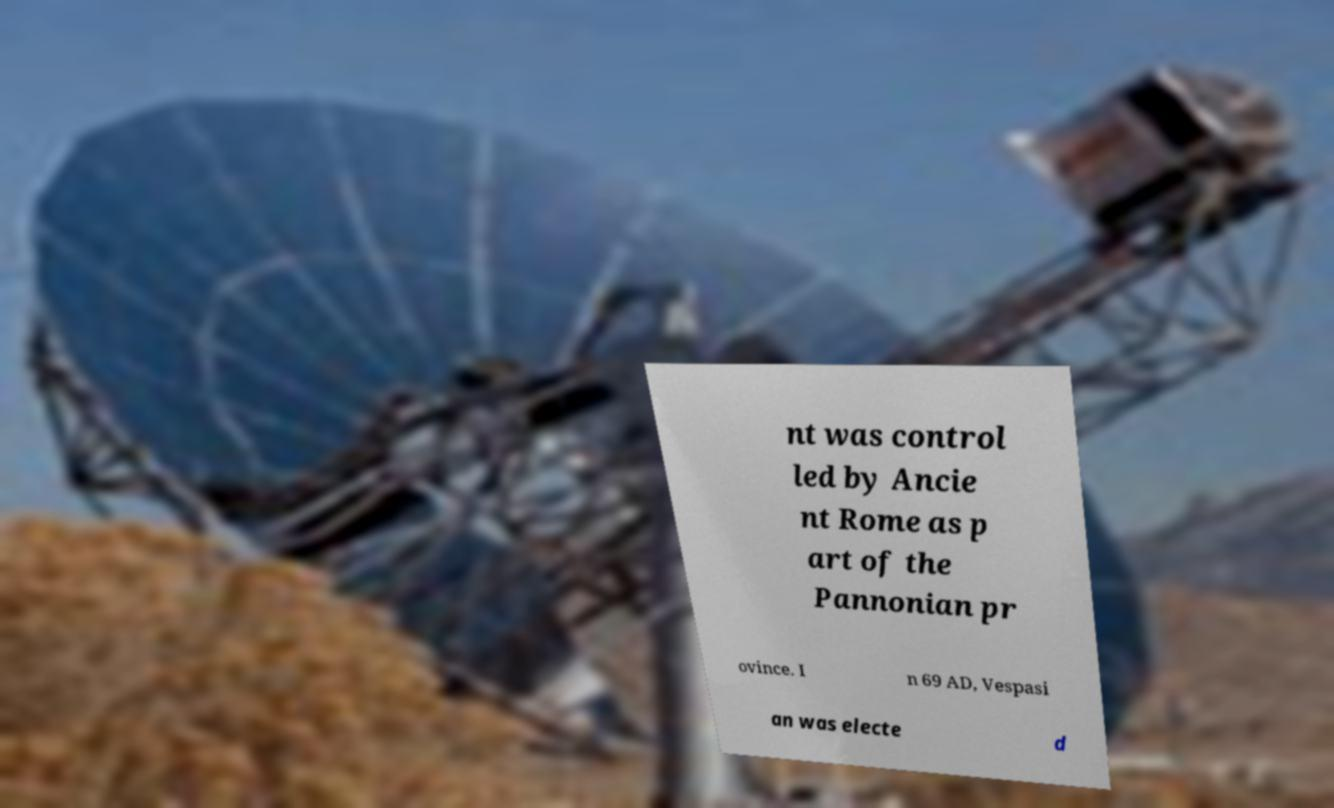Please read and relay the text visible in this image. What does it say? nt was control led by Ancie nt Rome as p art of the Pannonian pr ovince. I n 69 AD, Vespasi an was electe d 